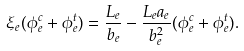Convert formula to latex. <formula><loc_0><loc_0><loc_500><loc_500>\xi _ { e } ( \phi _ { e } ^ { c } + \phi _ { e } ^ { t } ) & = \frac { L _ { e } } { b _ { e } } - \frac { L _ { e } a _ { e } } { b _ { e } ^ { 2 } } ( \phi _ { e } ^ { c } + \phi _ { e } ^ { t } ) .</formula> 